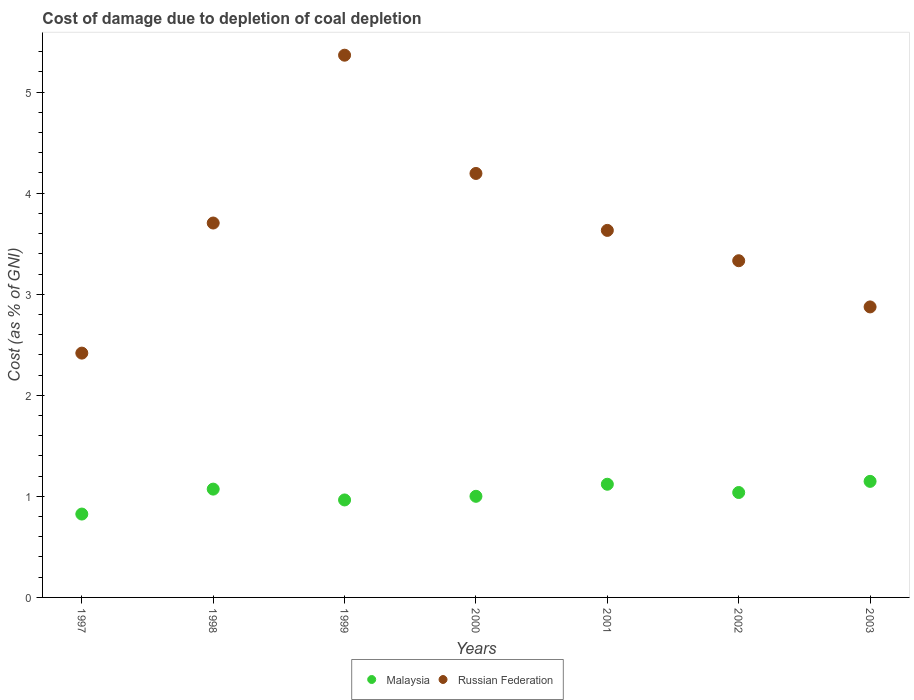What is the cost of damage caused due to coal depletion in Russian Federation in 2002?
Your answer should be compact. 3.33. Across all years, what is the maximum cost of damage caused due to coal depletion in Russian Federation?
Your response must be concise. 5.37. Across all years, what is the minimum cost of damage caused due to coal depletion in Malaysia?
Keep it short and to the point. 0.82. In which year was the cost of damage caused due to coal depletion in Russian Federation maximum?
Your answer should be very brief. 1999. In which year was the cost of damage caused due to coal depletion in Malaysia minimum?
Offer a very short reply. 1997. What is the total cost of damage caused due to coal depletion in Malaysia in the graph?
Your answer should be very brief. 7.17. What is the difference between the cost of damage caused due to coal depletion in Russian Federation in 1998 and that in 2003?
Give a very brief answer. 0.83. What is the difference between the cost of damage caused due to coal depletion in Russian Federation in 2000 and the cost of damage caused due to coal depletion in Malaysia in 2001?
Your answer should be very brief. 3.08. What is the average cost of damage caused due to coal depletion in Malaysia per year?
Ensure brevity in your answer.  1.02. In the year 2001, what is the difference between the cost of damage caused due to coal depletion in Malaysia and cost of damage caused due to coal depletion in Russian Federation?
Your answer should be compact. -2.51. In how many years, is the cost of damage caused due to coal depletion in Malaysia greater than 1.4 %?
Provide a short and direct response. 0. What is the ratio of the cost of damage caused due to coal depletion in Russian Federation in 1998 to that in 2000?
Give a very brief answer. 0.88. Is the difference between the cost of damage caused due to coal depletion in Malaysia in 1998 and 2003 greater than the difference between the cost of damage caused due to coal depletion in Russian Federation in 1998 and 2003?
Your answer should be compact. No. What is the difference between the highest and the second highest cost of damage caused due to coal depletion in Malaysia?
Offer a very short reply. 0.03. What is the difference between the highest and the lowest cost of damage caused due to coal depletion in Russian Federation?
Provide a succinct answer. 2.95. Is the sum of the cost of damage caused due to coal depletion in Malaysia in 1997 and 1998 greater than the maximum cost of damage caused due to coal depletion in Russian Federation across all years?
Your answer should be compact. No. Does the cost of damage caused due to coal depletion in Russian Federation monotonically increase over the years?
Offer a terse response. No. How many dotlines are there?
Your answer should be compact. 2. What is the difference between two consecutive major ticks on the Y-axis?
Give a very brief answer. 1. Are the values on the major ticks of Y-axis written in scientific E-notation?
Provide a succinct answer. No. Does the graph contain grids?
Keep it short and to the point. No. Where does the legend appear in the graph?
Your answer should be compact. Bottom center. How many legend labels are there?
Offer a very short reply. 2. How are the legend labels stacked?
Your answer should be compact. Horizontal. What is the title of the graph?
Offer a terse response. Cost of damage due to depletion of coal depletion. Does "Bulgaria" appear as one of the legend labels in the graph?
Keep it short and to the point. No. What is the label or title of the Y-axis?
Keep it short and to the point. Cost (as % of GNI). What is the Cost (as % of GNI) of Malaysia in 1997?
Your answer should be very brief. 0.82. What is the Cost (as % of GNI) of Russian Federation in 1997?
Provide a succinct answer. 2.42. What is the Cost (as % of GNI) of Malaysia in 1998?
Offer a terse response. 1.07. What is the Cost (as % of GNI) of Russian Federation in 1998?
Offer a very short reply. 3.7. What is the Cost (as % of GNI) in Malaysia in 1999?
Keep it short and to the point. 0.96. What is the Cost (as % of GNI) of Russian Federation in 1999?
Your response must be concise. 5.37. What is the Cost (as % of GNI) of Malaysia in 2000?
Keep it short and to the point. 1. What is the Cost (as % of GNI) in Russian Federation in 2000?
Provide a succinct answer. 4.19. What is the Cost (as % of GNI) in Malaysia in 2001?
Offer a terse response. 1.12. What is the Cost (as % of GNI) in Russian Federation in 2001?
Give a very brief answer. 3.63. What is the Cost (as % of GNI) of Malaysia in 2002?
Make the answer very short. 1.04. What is the Cost (as % of GNI) in Russian Federation in 2002?
Offer a terse response. 3.33. What is the Cost (as % of GNI) in Malaysia in 2003?
Ensure brevity in your answer.  1.15. What is the Cost (as % of GNI) of Russian Federation in 2003?
Keep it short and to the point. 2.87. Across all years, what is the maximum Cost (as % of GNI) in Malaysia?
Give a very brief answer. 1.15. Across all years, what is the maximum Cost (as % of GNI) in Russian Federation?
Your answer should be compact. 5.37. Across all years, what is the minimum Cost (as % of GNI) in Malaysia?
Offer a terse response. 0.82. Across all years, what is the minimum Cost (as % of GNI) of Russian Federation?
Keep it short and to the point. 2.42. What is the total Cost (as % of GNI) of Malaysia in the graph?
Your answer should be compact. 7.17. What is the total Cost (as % of GNI) of Russian Federation in the graph?
Provide a short and direct response. 25.52. What is the difference between the Cost (as % of GNI) of Malaysia in 1997 and that in 1998?
Your response must be concise. -0.25. What is the difference between the Cost (as % of GNI) of Russian Federation in 1997 and that in 1998?
Your answer should be very brief. -1.29. What is the difference between the Cost (as % of GNI) of Malaysia in 1997 and that in 1999?
Offer a terse response. -0.14. What is the difference between the Cost (as % of GNI) in Russian Federation in 1997 and that in 1999?
Provide a succinct answer. -2.95. What is the difference between the Cost (as % of GNI) in Malaysia in 1997 and that in 2000?
Keep it short and to the point. -0.18. What is the difference between the Cost (as % of GNI) in Russian Federation in 1997 and that in 2000?
Offer a terse response. -1.78. What is the difference between the Cost (as % of GNI) in Malaysia in 1997 and that in 2001?
Provide a succinct answer. -0.29. What is the difference between the Cost (as % of GNI) of Russian Federation in 1997 and that in 2001?
Keep it short and to the point. -1.21. What is the difference between the Cost (as % of GNI) of Malaysia in 1997 and that in 2002?
Your answer should be compact. -0.21. What is the difference between the Cost (as % of GNI) of Russian Federation in 1997 and that in 2002?
Offer a very short reply. -0.91. What is the difference between the Cost (as % of GNI) of Malaysia in 1997 and that in 2003?
Offer a very short reply. -0.32. What is the difference between the Cost (as % of GNI) in Russian Federation in 1997 and that in 2003?
Make the answer very short. -0.46. What is the difference between the Cost (as % of GNI) of Malaysia in 1998 and that in 1999?
Ensure brevity in your answer.  0.11. What is the difference between the Cost (as % of GNI) of Russian Federation in 1998 and that in 1999?
Ensure brevity in your answer.  -1.66. What is the difference between the Cost (as % of GNI) in Malaysia in 1998 and that in 2000?
Your answer should be very brief. 0.07. What is the difference between the Cost (as % of GNI) in Russian Federation in 1998 and that in 2000?
Give a very brief answer. -0.49. What is the difference between the Cost (as % of GNI) in Malaysia in 1998 and that in 2001?
Keep it short and to the point. -0.05. What is the difference between the Cost (as % of GNI) of Russian Federation in 1998 and that in 2001?
Ensure brevity in your answer.  0.07. What is the difference between the Cost (as % of GNI) in Malaysia in 1998 and that in 2002?
Give a very brief answer. 0.03. What is the difference between the Cost (as % of GNI) in Russian Federation in 1998 and that in 2002?
Offer a very short reply. 0.37. What is the difference between the Cost (as % of GNI) of Malaysia in 1998 and that in 2003?
Your answer should be very brief. -0.08. What is the difference between the Cost (as % of GNI) of Russian Federation in 1998 and that in 2003?
Give a very brief answer. 0.83. What is the difference between the Cost (as % of GNI) of Malaysia in 1999 and that in 2000?
Ensure brevity in your answer.  -0.04. What is the difference between the Cost (as % of GNI) in Russian Federation in 1999 and that in 2000?
Give a very brief answer. 1.17. What is the difference between the Cost (as % of GNI) in Malaysia in 1999 and that in 2001?
Make the answer very short. -0.16. What is the difference between the Cost (as % of GNI) in Russian Federation in 1999 and that in 2001?
Your response must be concise. 1.73. What is the difference between the Cost (as % of GNI) of Malaysia in 1999 and that in 2002?
Keep it short and to the point. -0.07. What is the difference between the Cost (as % of GNI) of Russian Federation in 1999 and that in 2002?
Your response must be concise. 2.03. What is the difference between the Cost (as % of GNI) of Malaysia in 1999 and that in 2003?
Your response must be concise. -0.18. What is the difference between the Cost (as % of GNI) of Russian Federation in 1999 and that in 2003?
Ensure brevity in your answer.  2.49. What is the difference between the Cost (as % of GNI) of Malaysia in 2000 and that in 2001?
Offer a very short reply. -0.12. What is the difference between the Cost (as % of GNI) in Russian Federation in 2000 and that in 2001?
Ensure brevity in your answer.  0.56. What is the difference between the Cost (as % of GNI) of Malaysia in 2000 and that in 2002?
Your answer should be very brief. -0.04. What is the difference between the Cost (as % of GNI) in Russian Federation in 2000 and that in 2002?
Keep it short and to the point. 0.86. What is the difference between the Cost (as % of GNI) of Malaysia in 2000 and that in 2003?
Offer a very short reply. -0.15. What is the difference between the Cost (as % of GNI) in Russian Federation in 2000 and that in 2003?
Offer a terse response. 1.32. What is the difference between the Cost (as % of GNI) in Malaysia in 2001 and that in 2002?
Your answer should be compact. 0.08. What is the difference between the Cost (as % of GNI) of Russian Federation in 2001 and that in 2002?
Provide a short and direct response. 0.3. What is the difference between the Cost (as % of GNI) in Malaysia in 2001 and that in 2003?
Your response must be concise. -0.03. What is the difference between the Cost (as % of GNI) in Russian Federation in 2001 and that in 2003?
Your answer should be compact. 0.76. What is the difference between the Cost (as % of GNI) of Malaysia in 2002 and that in 2003?
Your answer should be compact. -0.11. What is the difference between the Cost (as % of GNI) of Russian Federation in 2002 and that in 2003?
Give a very brief answer. 0.46. What is the difference between the Cost (as % of GNI) in Malaysia in 1997 and the Cost (as % of GNI) in Russian Federation in 1998?
Provide a short and direct response. -2.88. What is the difference between the Cost (as % of GNI) in Malaysia in 1997 and the Cost (as % of GNI) in Russian Federation in 1999?
Keep it short and to the point. -4.54. What is the difference between the Cost (as % of GNI) in Malaysia in 1997 and the Cost (as % of GNI) in Russian Federation in 2000?
Make the answer very short. -3.37. What is the difference between the Cost (as % of GNI) in Malaysia in 1997 and the Cost (as % of GNI) in Russian Federation in 2001?
Make the answer very short. -2.81. What is the difference between the Cost (as % of GNI) of Malaysia in 1997 and the Cost (as % of GNI) of Russian Federation in 2002?
Keep it short and to the point. -2.51. What is the difference between the Cost (as % of GNI) in Malaysia in 1997 and the Cost (as % of GNI) in Russian Federation in 2003?
Give a very brief answer. -2.05. What is the difference between the Cost (as % of GNI) of Malaysia in 1998 and the Cost (as % of GNI) of Russian Federation in 1999?
Your answer should be very brief. -4.29. What is the difference between the Cost (as % of GNI) in Malaysia in 1998 and the Cost (as % of GNI) in Russian Federation in 2000?
Offer a terse response. -3.12. What is the difference between the Cost (as % of GNI) in Malaysia in 1998 and the Cost (as % of GNI) in Russian Federation in 2001?
Your response must be concise. -2.56. What is the difference between the Cost (as % of GNI) in Malaysia in 1998 and the Cost (as % of GNI) in Russian Federation in 2002?
Offer a very short reply. -2.26. What is the difference between the Cost (as % of GNI) in Malaysia in 1998 and the Cost (as % of GNI) in Russian Federation in 2003?
Make the answer very short. -1.8. What is the difference between the Cost (as % of GNI) in Malaysia in 1999 and the Cost (as % of GNI) in Russian Federation in 2000?
Ensure brevity in your answer.  -3.23. What is the difference between the Cost (as % of GNI) in Malaysia in 1999 and the Cost (as % of GNI) in Russian Federation in 2001?
Your answer should be compact. -2.67. What is the difference between the Cost (as % of GNI) of Malaysia in 1999 and the Cost (as % of GNI) of Russian Federation in 2002?
Your response must be concise. -2.37. What is the difference between the Cost (as % of GNI) of Malaysia in 1999 and the Cost (as % of GNI) of Russian Federation in 2003?
Keep it short and to the point. -1.91. What is the difference between the Cost (as % of GNI) of Malaysia in 2000 and the Cost (as % of GNI) of Russian Federation in 2001?
Offer a very short reply. -2.63. What is the difference between the Cost (as % of GNI) of Malaysia in 2000 and the Cost (as % of GNI) of Russian Federation in 2002?
Ensure brevity in your answer.  -2.33. What is the difference between the Cost (as % of GNI) of Malaysia in 2000 and the Cost (as % of GNI) of Russian Federation in 2003?
Your response must be concise. -1.87. What is the difference between the Cost (as % of GNI) of Malaysia in 2001 and the Cost (as % of GNI) of Russian Federation in 2002?
Offer a terse response. -2.21. What is the difference between the Cost (as % of GNI) of Malaysia in 2001 and the Cost (as % of GNI) of Russian Federation in 2003?
Your answer should be very brief. -1.75. What is the difference between the Cost (as % of GNI) of Malaysia in 2002 and the Cost (as % of GNI) of Russian Federation in 2003?
Offer a terse response. -1.84. What is the average Cost (as % of GNI) of Russian Federation per year?
Your response must be concise. 3.65. In the year 1997, what is the difference between the Cost (as % of GNI) in Malaysia and Cost (as % of GNI) in Russian Federation?
Provide a short and direct response. -1.59. In the year 1998, what is the difference between the Cost (as % of GNI) in Malaysia and Cost (as % of GNI) in Russian Federation?
Give a very brief answer. -2.63. In the year 1999, what is the difference between the Cost (as % of GNI) in Malaysia and Cost (as % of GNI) in Russian Federation?
Your answer should be compact. -4.4. In the year 2000, what is the difference between the Cost (as % of GNI) in Malaysia and Cost (as % of GNI) in Russian Federation?
Make the answer very short. -3.19. In the year 2001, what is the difference between the Cost (as % of GNI) of Malaysia and Cost (as % of GNI) of Russian Federation?
Offer a terse response. -2.51. In the year 2002, what is the difference between the Cost (as % of GNI) in Malaysia and Cost (as % of GNI) in Russian Federation?
Ensure brevity in your answer.  -2.29. In the year 2003, what is the difference between the Cost (as % of GNI) in Malaysia and Cost (as % of GNI) in Russian Federation?
Keep it short and to the point. -1.73. What is the ratio of the Cost (as % of GNI) of Malaysia in 1997 to that in 1998?
Provide a succinct answer. 0.77. What is the ratio of the Cost (as % of GNI) of Russian Federation in 1997 to that in 1998?
Offer a very short reply. 0.65. What is the ratio of the Cost (as % of GNI) in Malaysia in 1997 to that in 1999?
Your answer should be compact. 0.86. What is the ratio of the Cost (as % of GNI) of Russian Federation in 1997 to that in 1999?
Offer a terse response. 0.45. What is the ratio of the Cost (as % of GNI) of Malaysia in 1997 to that in 2000?
Offer a very short reply. 0.82. What is the ratio of the Cost (as % of GNI) of Russian Federation in 1997 to that in 2000?
Provide a succinct answer. 0.58. What is the ratio of the Cost (as % of GNI) in Malaysia in 1997 to that in 2001?
Provide a succinct answer. 0.74. What is the ratio of the Cost (as % of GNI) of Russian Federation in 1997 to that in 2001?
Keep it short and to the point. 0.67. What is the ratio of the Cost (as % of GNI) of Malaysia in 1997 to that in 2002?
Provide a short and direct response. 0.79. What is the ratio of the Cost (as % of GNI) in Russian Federation in 1997 to that in 2002?
Ensure brevity in your answer.  0.73. What is the ratio of the Cost (as % of GNI) of Malaysia in 1997 to that in 2003?
Offer a terse response. 0.72. What is the ratio of the Cost (as % of GNI) of Russian Federation in 1997 to that in 2003?
Give a very brief answer. 0.84. What is the ratio of the Cost (as % of GNI) in Malaysia in 1998 to that in 1999?
Provide a succinct answer. 1.11. What is the ratio of the Cost (as % of GNI) of Russian Federation in 1998 to that in 1999?
Your answer should be compact. 0.69. What is the ratio of the Cost (as % of GNI) of Malaysia in 1998 to that in 2000?
Ensure brevity in your answer.  1.07. What is the ratio of the Cost (as % of GNI) in Russian Federation in 1998 to that in 2000?
Offer a very short reply. 0.88. What is the ratio of the Cost (as % of GNI) of Malaysia in 1998 to that in 2001?
Offer a terse response. 0.96. What is the ratio of the Cost (as % of GNI) in Russian Federation in 1998 to that in 2001?
Your answer should be compact. 1.02. What is the ratio of the Cost (as % of GNI) of Malaysia in 1998 to that in 2002?
Make the answer very short. 1.03. What is the ratio of the Cost (as % of GNI) in Russian Federation in 1998 to that in 2002?
Your answer should be very brief. 1.11. What is the ratio of the Cost (as % of GNI) in Malaysia in 1998 to that in 2003?
Your answer should be very brief. 0.93. What is the ratio of the Cost (as % of GNI) in Russian Federation in 1998 to that in 2003?
Make the answer very short. 1.29. What is the ratio of the Cost (as % of GNI) in Malaysia in 1999 to that in 2000?
Your answer should be compact. 0.96. What is the ratio of the Cost (as % of GNI) in Russian Federation in 1999 to that in 2000?
Your answer should be compact. 1.28. What is the ratio of the Cost (as % of GNI) of Malaysia in 1999 to that in 2001?
Your response must be concise. 0.86. What is the ratio of the Cost (as % of GNI) in Russian Federation in 1999 to that in 2001?
Your answer should be compact. 1.48. What is the ratio of the Cost (as % of GNI) of Malaysia in 1999 to that in 2002?
Offer a terse response. 0.93. What is the ratio of the Cost (as % of GNI) of Russian Federation in 1999 to that in 2002?
Your answer should be compact. 1.61. What is the ratio of the Cost (as % of GNI) of Malaysia in 1999 to that in 2003?
Offer a terse response. 0.84. What is the ratio of the Cost (as % of GNI) in Russian Federation in 1999 to that in 2003?
Keep it short and to the point. 1.87. What is the ratio of the Cost (as % of GNI) in Malaysia in 2000 to that in 2001?
Your answer should be compact. 0.89. What is the ratio of the Cost (as % of GNI) of Russian Federation in 2000 to that in 2001?
Give a very brief answer. 1.16. What is the ratio of the Cost (as % of GNI) of Malaysia in 2000 to that in 2002?
Your response must be concise. 0.96. What is the ratio of the Cost (as % of GNI) of Russian Federation in 2000 to that in 2002?
Offer a terse response. 1.26. What is the ratio of the Cost (as % of GNI) of Malaysia in 2000 to that in 2003?
Offer a very short reply. 0.87. What is the ratio of the Cost (as % of GNI) of Russian Federation in 2000 to that in 2003?
Provide a succinct answer. 1.46. What is the ratio of the Cost (as % of GNI) of Malaysia in 2001 to that in 2002?
Offer a terse response. 1.08. What is the ratio of the Cost (as % of GNI) in Russian Federation in 2001 to that in 2002?
Keep it short and to the point. 1.09. What is the ratio of the Cost (as % of GNI) of Malaysia in 2001 to that in 2003?
Offer a very short reply. 0.98. What is the ratio of the Cost (as % of GNI) of Russian Federation in 2001 to that in 2003?
Your answer should be very brief. 1.26. What is the ratio of the Cost (as % of GNI) in Malaysia in 2002 to that in 2003?
Your answer should be very brief. 0.9. What is the ratio of the Cost (as % of GNI) of Russian Federation in 2002 to that in 2003?
Keep it short and to the point. 1.16. What is the difference between the highest and the second highest Cost (as % of GNI) of Malaysia?
Your answer should be very brief. 0.03. What is the difference between the highest and the second highest Cost (as % of GNI) of Russian Federation?
Give a very brief answer. 1.17. What is the difference between the highest and the lowest Cost (as % of GNI) in Malaysia?
Your response must be concise. 0.32. What is the difference between the highest and the lowest Cost (as % of GNI) of Russian Federation?
Make the answer very short. 2.95. 